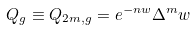Convert formula to latex. <formula><loc_0><loc_0><loc_500><loc_500>Q _ { g } \equiv Q _ { 2 m , g } = e ^ { - n w } \Delta ^ { m } w</formula> 